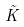<formula> <loc_0><loc_0><loc_500><loc_500>\tilde { K }</formula> 